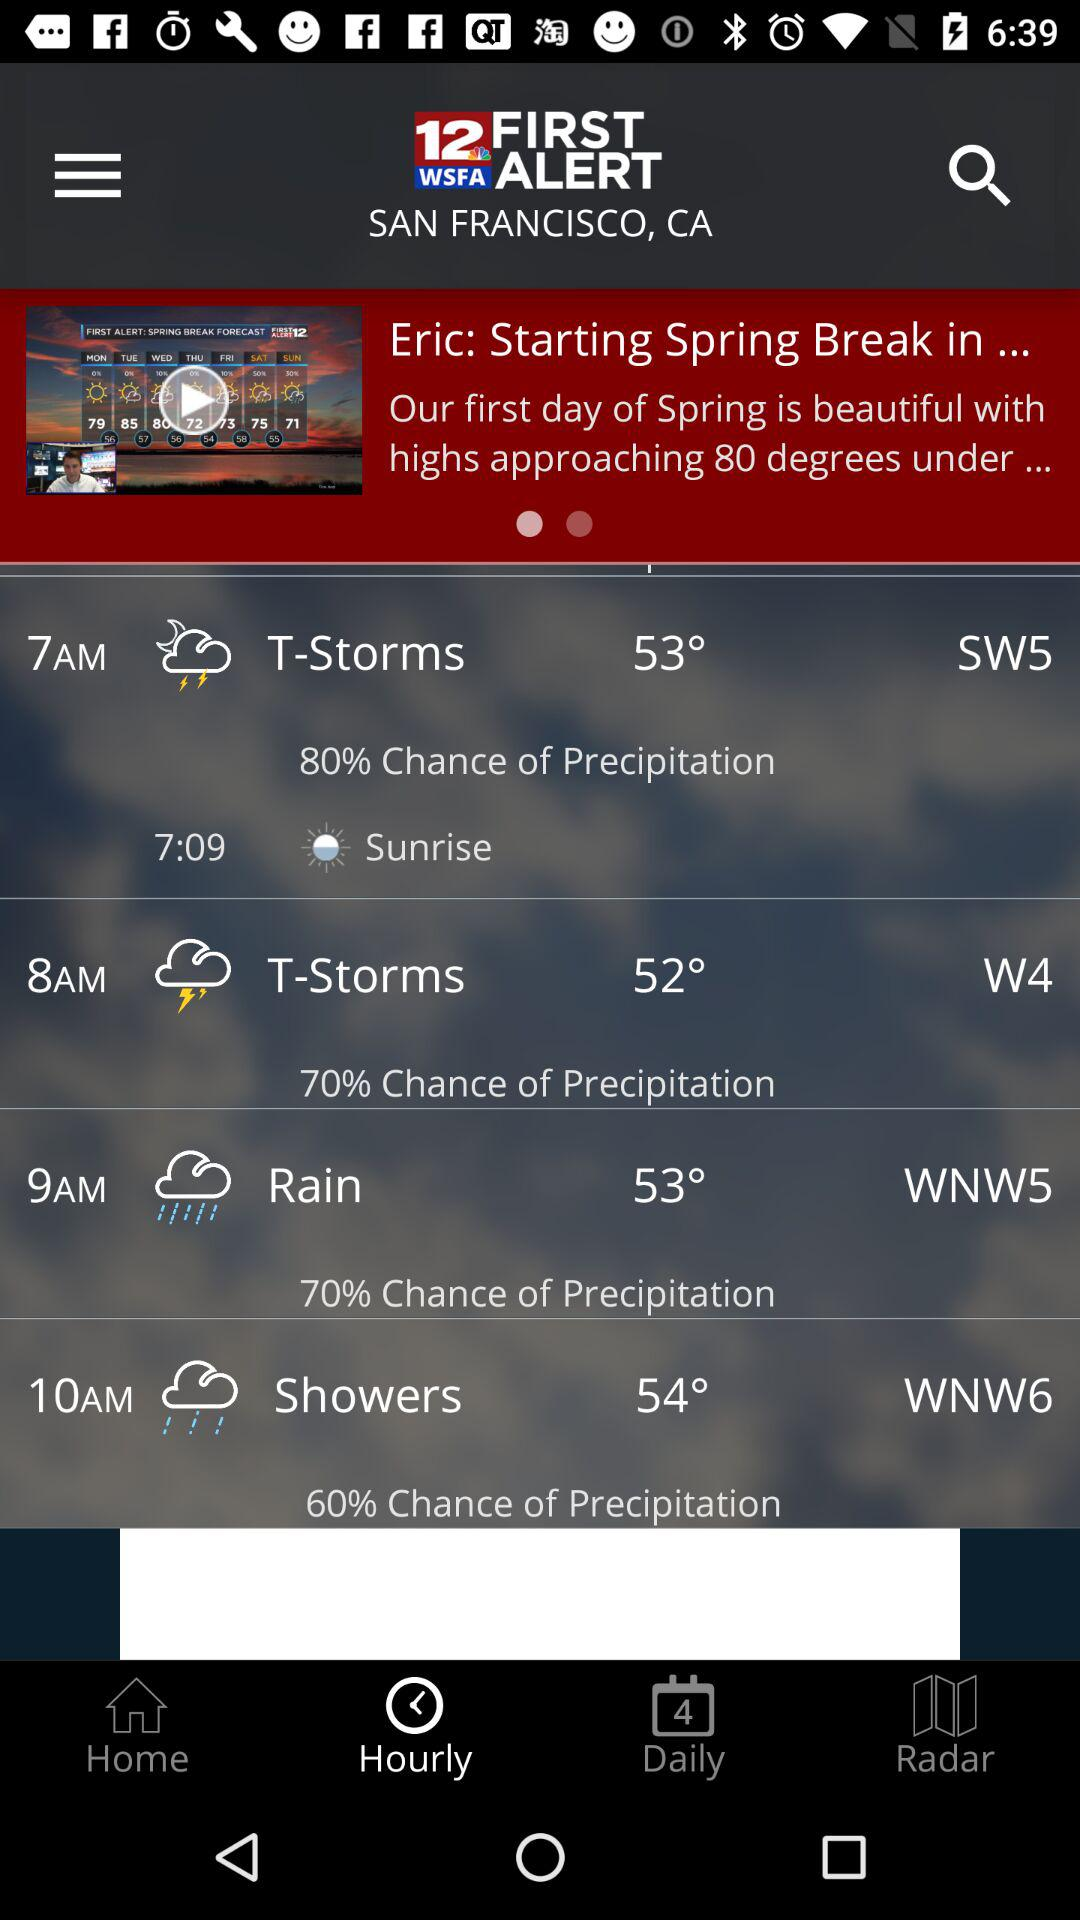What is the percentage chance of precipitation at 9am?
Answer the question using a single word or phrase. 70% 